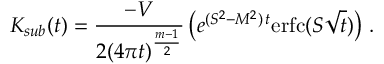<formula> <loc_0><loc_0><loc_500><loc_500>K _ { s u b } ( t ) = \frac { - V } { 2 ( 4 \pi t ) ^ { \frac { m - 1 } 2 } } \left ( e ^ { ( S ^ { 2 } - M ^ { 2 } ) \, t } e r f c ( S \sqrt { t } ) \right ) \, .</formula> 